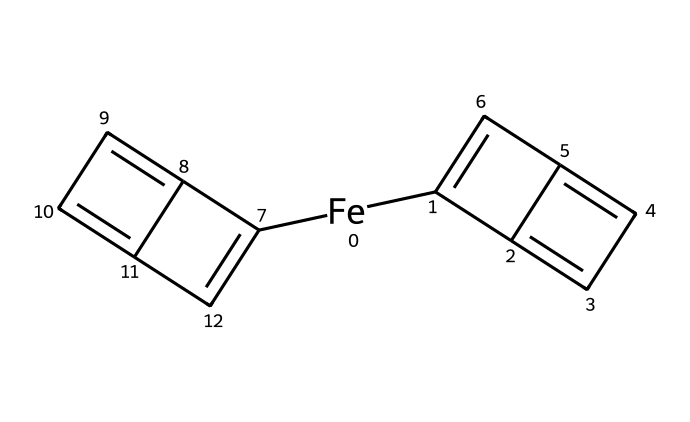What is the central metal atom in ferrocene? The central metal atom is represented by the symbol "Fe" in the SMILES notation, where the chemical structure indicates that the iron atom is bonded to two cyclopentadienyl anions.
Answer: iron How many cyclopentadienyl rings are present in ferrocene? The structure shows two distinct cyclopentadienyl rings, each corresponding to the part of the molecule represented as "C1=C" and "C3=C." This indicates that there are two cyclic structures surrounding the iron center.
Answer: two What is the hybridization of the central metal atom in ferrocene? The iron atom in ferrocene is typically in an oxidation state of +2 or +3, with a d orbital involvement that leads to sp² hybridization for bonding efficiency with the surrounding ligands.
Answer: sp² What type of bonding is present between the iron atom and the cyclopentadienyl rings? The bonding between the iron atom and the cyclopentadienyl rings involves coordinate covalent bonds, where the rings donate electron density to the iron atom as it accepts them.
Answer: coordinate covalent How does the structure of ferrocene allow for its stability? The sandwich-like structure with two cyclopentadienyl rings encapsulating the iron atom provides a highly stable arrangement due to parallel alignment and delocalization of π electrons across the rings, creating resonance stabilization.
Answer: resonance stabilization 